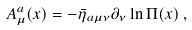Convert formula to latex. <formula><loc_0><loc_0><loc_500><loc_500>A _ { \mu } ^ { a } ( x ) = - \bar { \eta } _ { a \mu \nu } \partial _ { \nu } \ln \Pi ( x ) \, ,</formula> 